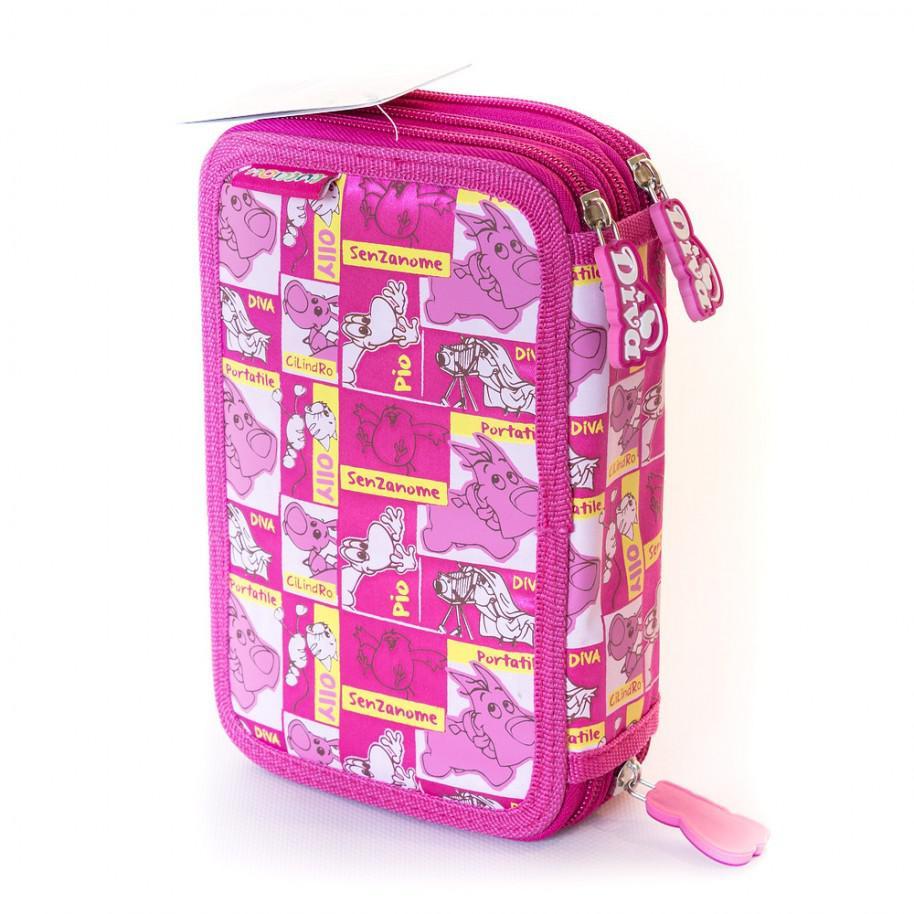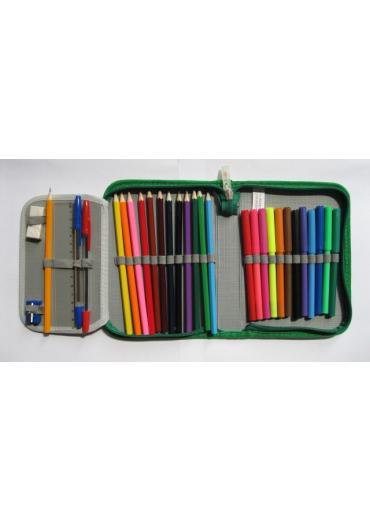The first image is the image on the left, the second image is the image on the right. Given the left and right images, does the statement "The case in one of the images is opened to reveal its contents." hold true? Answer yes or no. Yes. The first image is the image on the left, the second image is the image on the right. Examine the images to the left and right. Is the description "There are writing utensils visible in one of the images." accurate? Answer yes or no. Yes. 